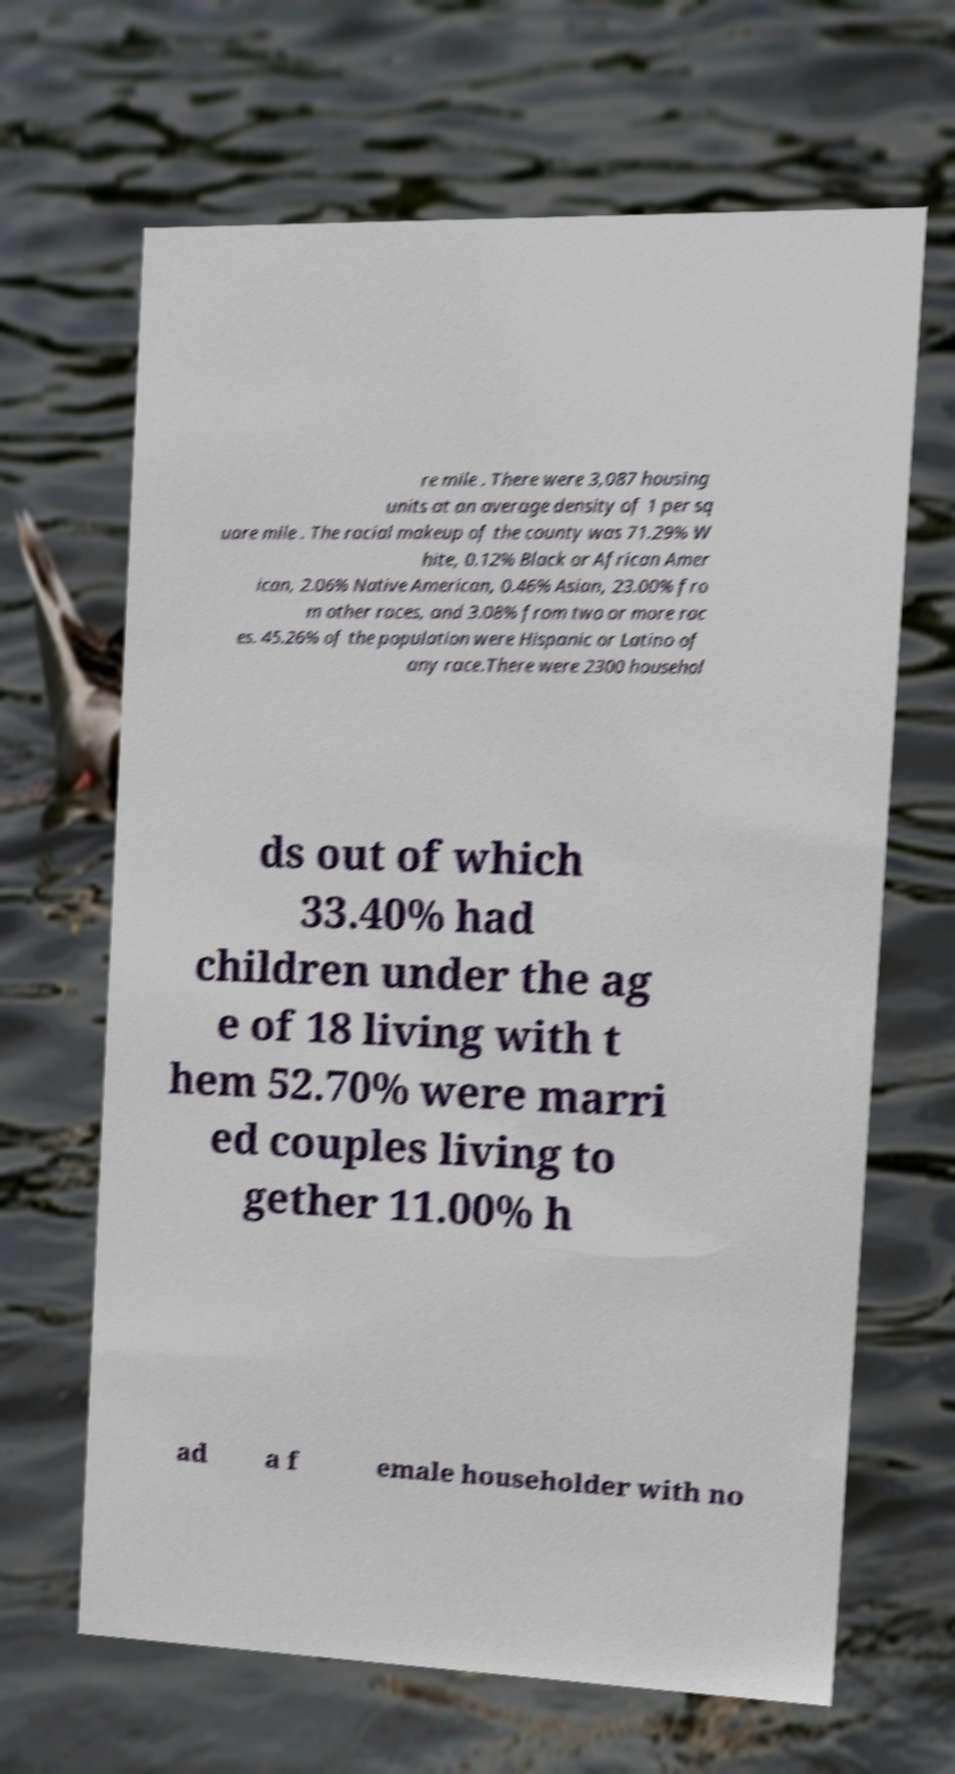Could you assist in decoding the text presented in this image and type it out clearly? re mile . There were 3,087 housing units at an average density of 1 per sq uare mile . The racial makeup of the county was 71.29% W hite, 0.12% Black or African Amer ican, 2.06% Native American, 0.46% Asian, 23.00% fro m other races, and 3.08% from two or more rac es. 45.26% of the population were Hispanic or Latino of any race.There were 2300 househol ds out of which 33.40% had children under the ag e of 18 living with t hem 52.70% were marri ed couples living to gether 11.00% h ad a f emale householder with no 